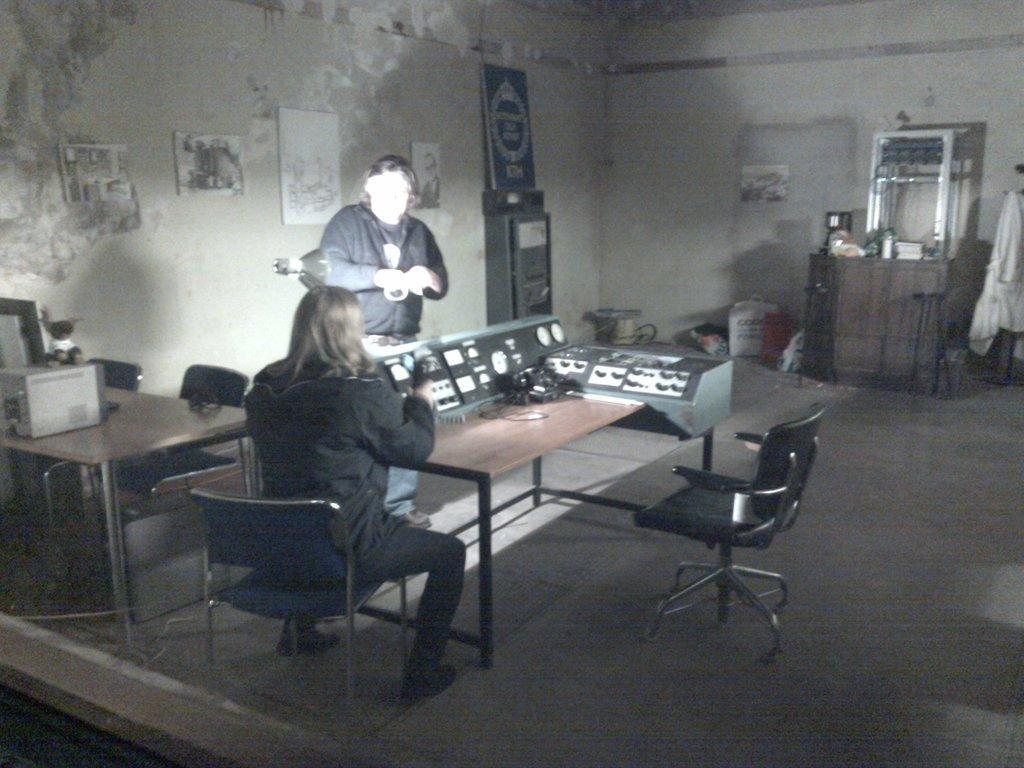In one or two sentences, can you explain what this image depicts? In this image I can see two people. One person is sitting on the chair and one person is standing. I can see the table in-front of these people. I can see some electronic gadgets on it. In the back I can see some boards to the wall. To the right I can see the cupboards and I can see some objects on it. I can also see the cloth to the right. 